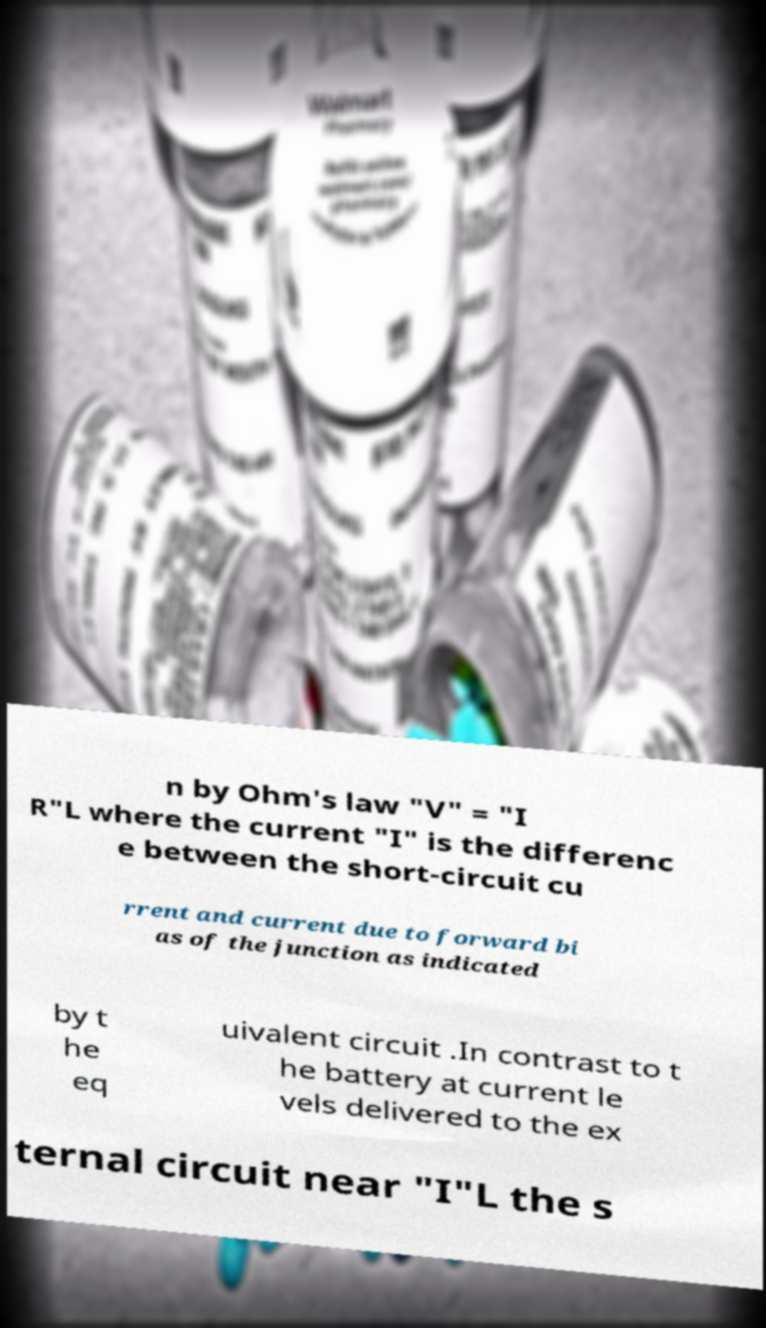Can you read and provide the text displayed in the image?This photo seems to have some interesting text. Can you extract and type it out for me? n by Ohm's law "V" = "I R"L where the current "I" is the differenc e between the short-circuit cu rrent and current due to forward bi as of the junction as indicated by t he eq uivalent circuit .In contrast to t he battery at current le vels delivered to the ex ternal circuit near "I"L the s 